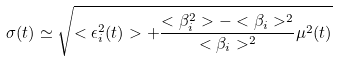<formula> <loc_0><loc_0><loc_500><loc_500>\sigma ( t ) \simeq \sqrt { < \epsilon _ { i } ^ { 2 } ( t ) > + \frac { < \beta _ { i } ^ { 2 } > - < \beta _ { i } > ^ { 2 } } { < \beta _ { i } > ^ { 2 } } \mu ^ { 2 } ( t ) }</formula> 